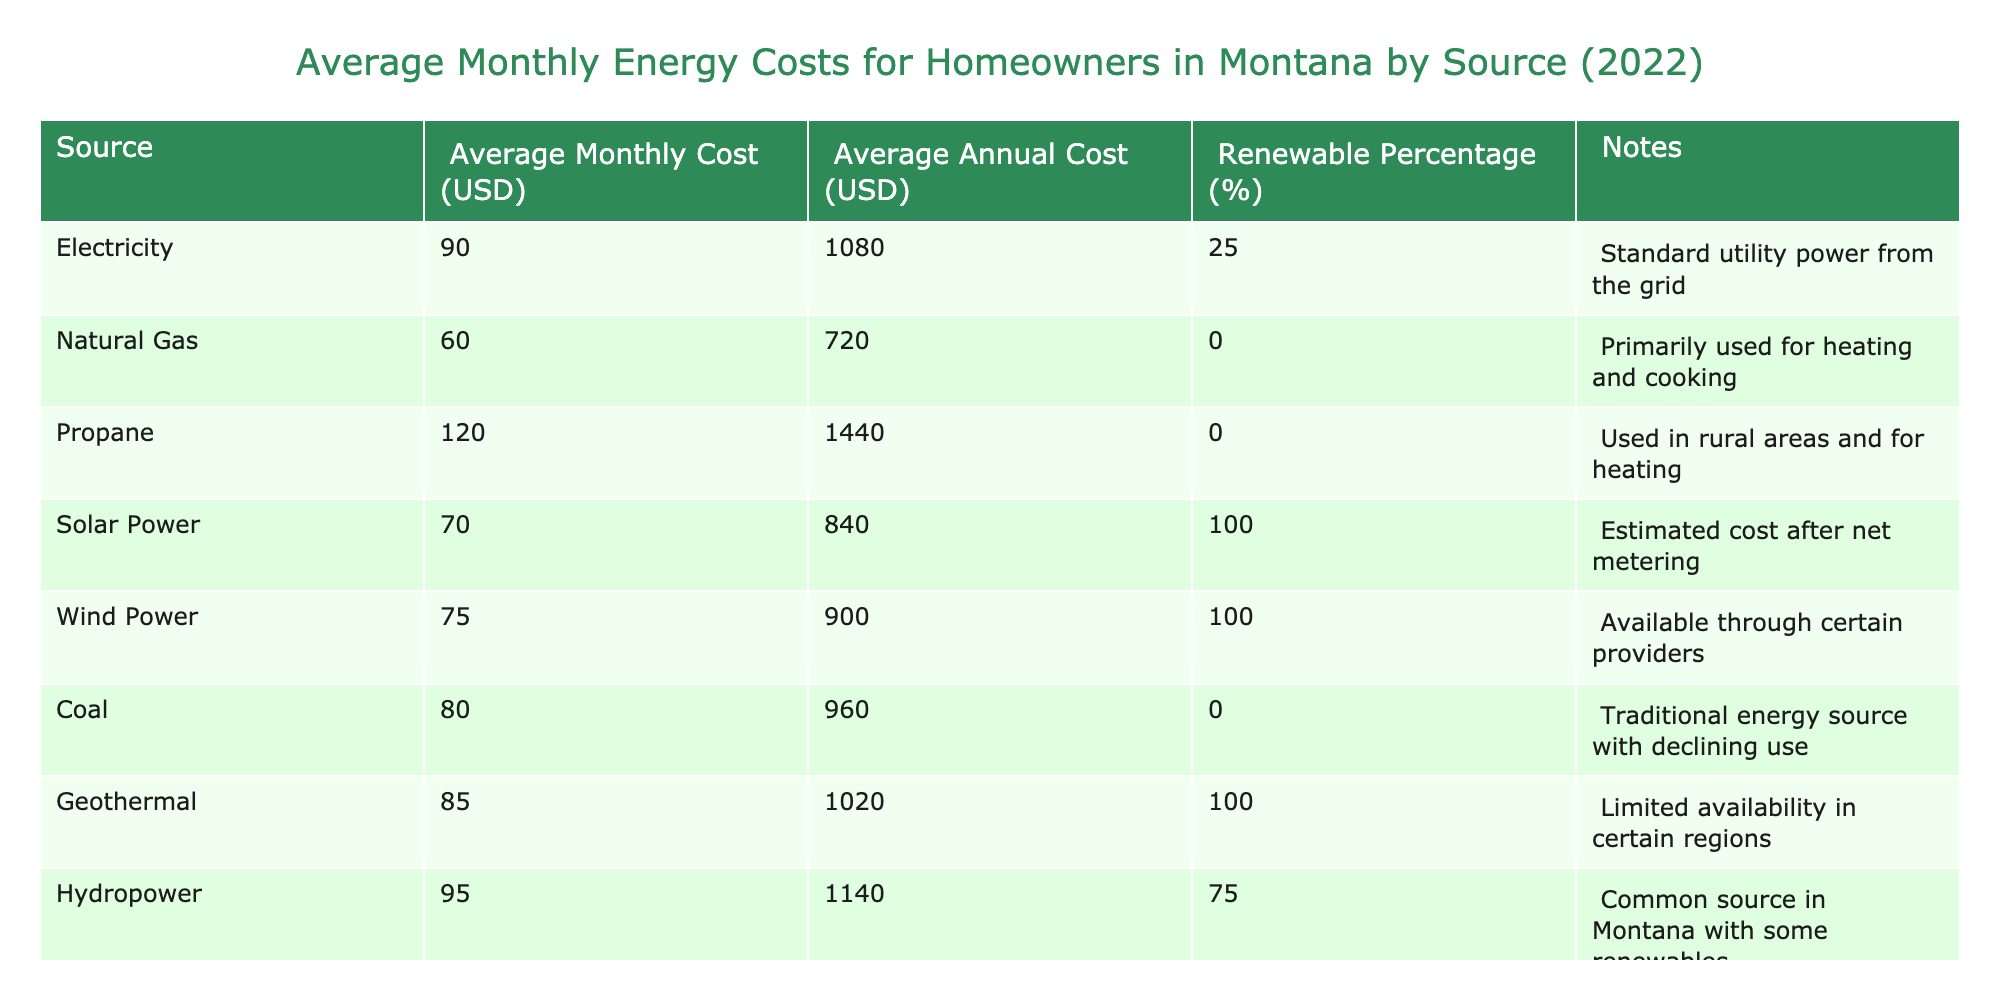What is the average monthly cost of using solar power in Montana? The table lists the average monthly cost of solar power as 70 USD.
Answer: 70 USD Which energy source has the highest average monthly cost? The table indicates that propane has the highest average monthly cost at 120 USD.
Answer: 120 USD What is the total average monthly cost of natural gas and biomass combined? The average monthly cost of natural gas is 60 USD and for biomass, it is 65 USD. Adding these values gives 60 + 65 = 125 USD.
Answer: 125 USD Is the renewable percentage of electricity above 50%? The renewable percentage for electricity is stated as 25%, which is not above 50%.
Answer: No Which energy sources have a renewable percentage of 100%? According to the table, the sources with 100% renewable percentage are solar power, wind power, and geothermal energy.
Answer: Solar power, wind power, geothermal If a homeowner uses hydropower, what is their average annual cost? The average annual cost of hydropower is provided in the table as 1140 USD.
Answer: 1140 USD What is the average monthly cost difference between coal and electricity? From the table, the average monthly cost of coal is 80 USD and for electricity, it is 90 USD. The difference is calculated as 90 - 80 = 10 USD.
Answer: 10 USD Are the average monthly costs of all renewable sources combined higher than the average monthly cost of electricity? First, we need to find the average monthly costs of the renewable sources: solar power (70 USD), wind power (75 USD), geothermal (85 USD), and hydropower (95 USD). The total is 70 + 75 + 85 + 95 = 325 USD, divided by 4 gives an average of 81.25 USD. Since 81.25 USD is less than the electricity cost of 90 USD, the statement is false.
Answer: No Which source has an average monthly cost less than or equal to 75 USD? Referring to the table, the sources with costs below or equal to 75 USD are natural gas (60 USD) and biomass (65 USD).
Answer: Natural gas, biomass 